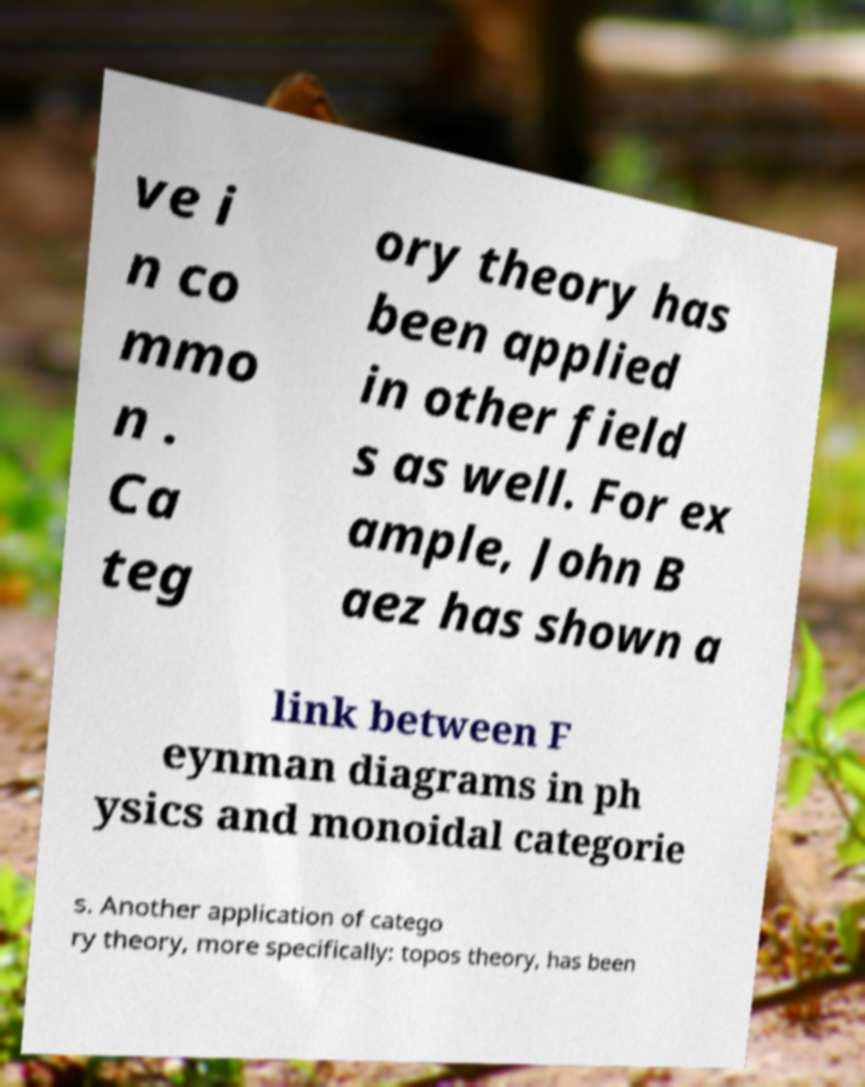Please identify and transcribe the text found in this image. ve i n co mmo n . Ca teg ory theory has been applied in other field s as well. For ex ample, John B aez has shown a link between F eynman diagrams in ph ysics and monoidal categorie s. Another application of catego ry theory, more specifically: topos theory, has been 